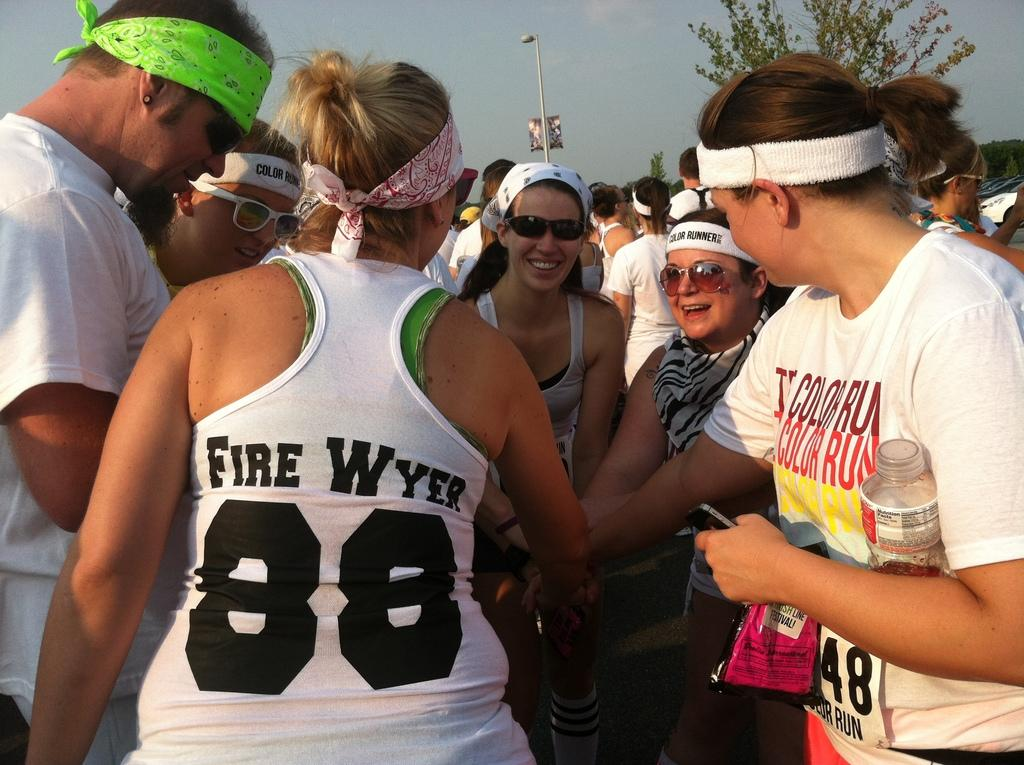<image>
Summarize the visual content of the image. a few people huddled up, one that has the number 88 on 